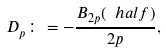Convert formula to latex. <formula><loc_0><loc_0><loc_500><loc_500>D _ { p } \colon = - \frac { B _ { 2 p } ( \ h a l f ) } { 2 p } ,</formula> 